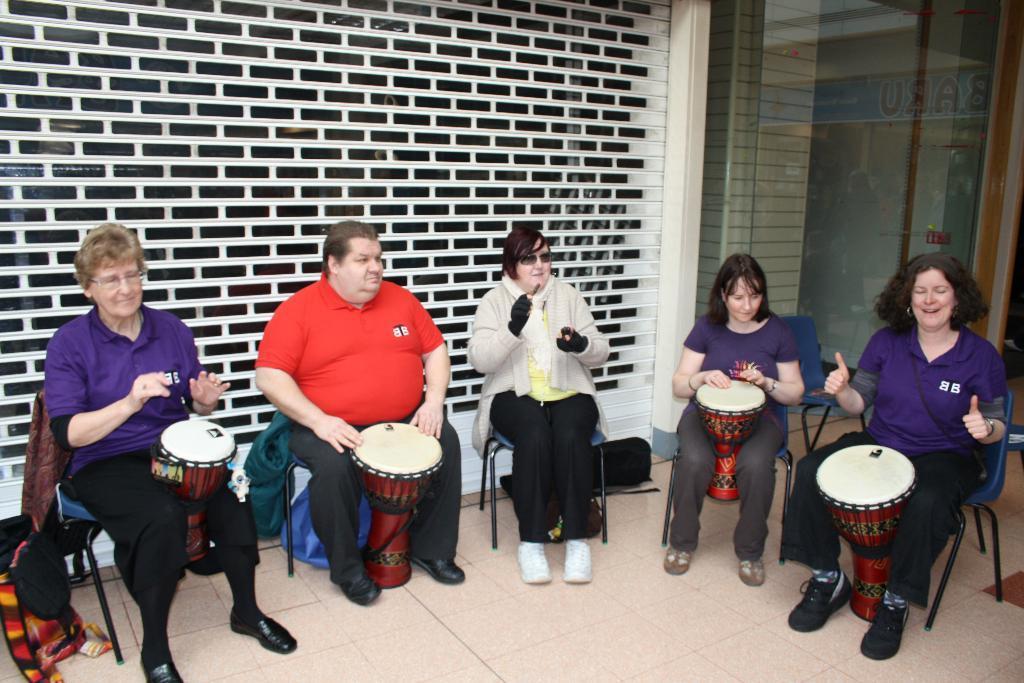Can you describe this image briefly? In this Image I see 4 women and a man who are sitting on chairs and I see there are 4 drums and this woman is smiling, In the background I see the wall, glass and few things over here. 